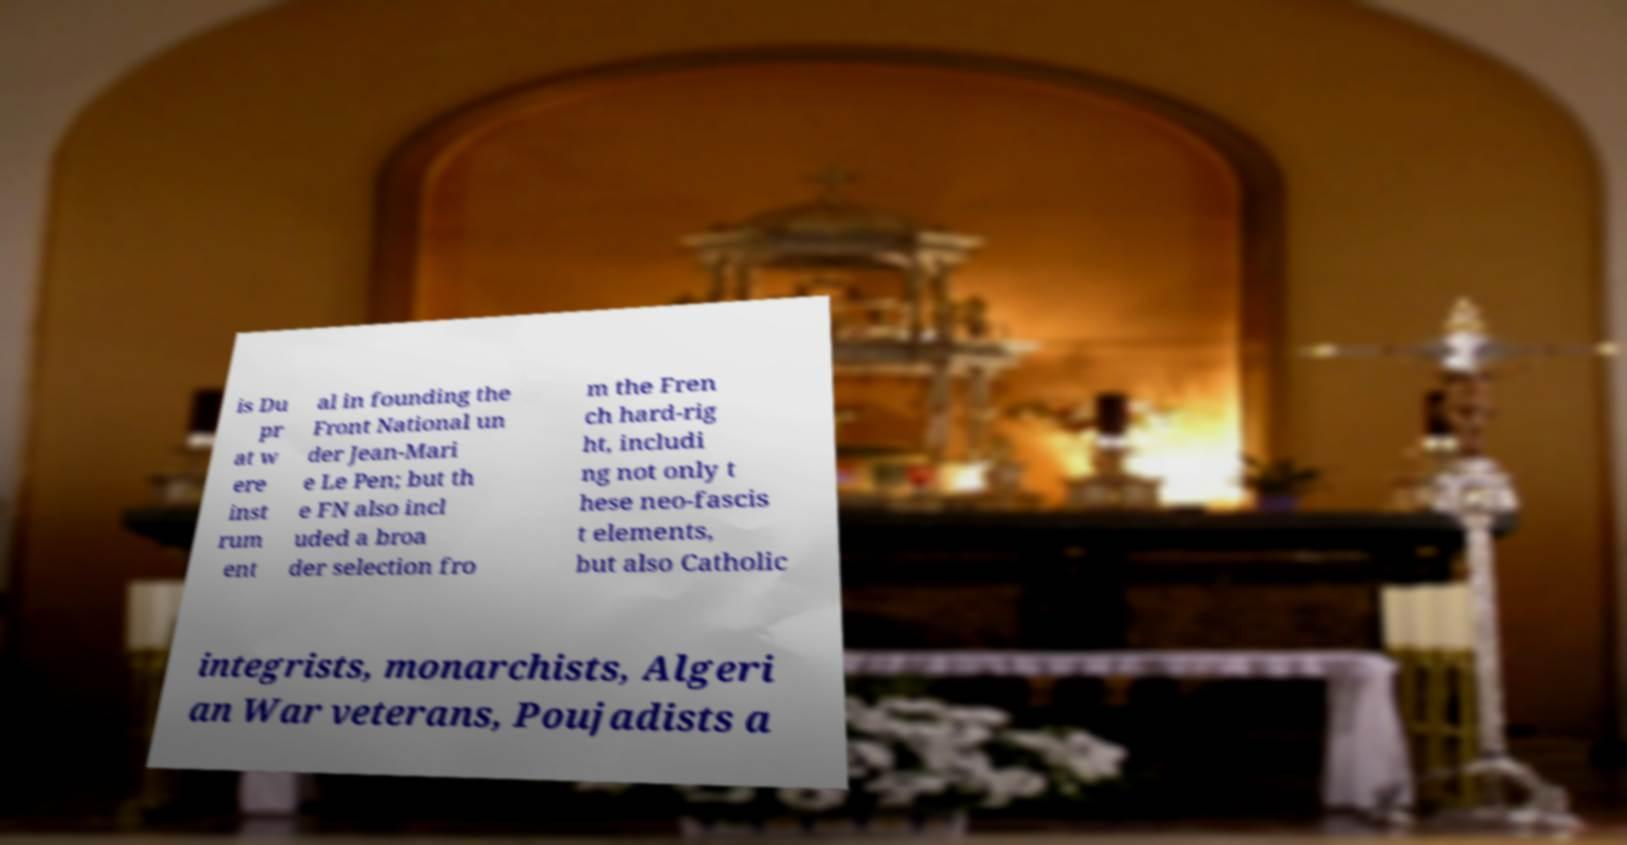Can you read and provide the text displayed in the image?This photo seems to have some interesting text. Can you extract and type it out for me? is Du pr at w ere inst rum ent al in founding the Front National un der Jean-Mari e Le Pen; but th e FN also incl uded a broa der selection fro m the Fren ch hard-rig ht, includi ng not only t hese neo-fascis t elements, but also Catholic integrists, monarchists, Algeri an War veterans, Poujadists a 